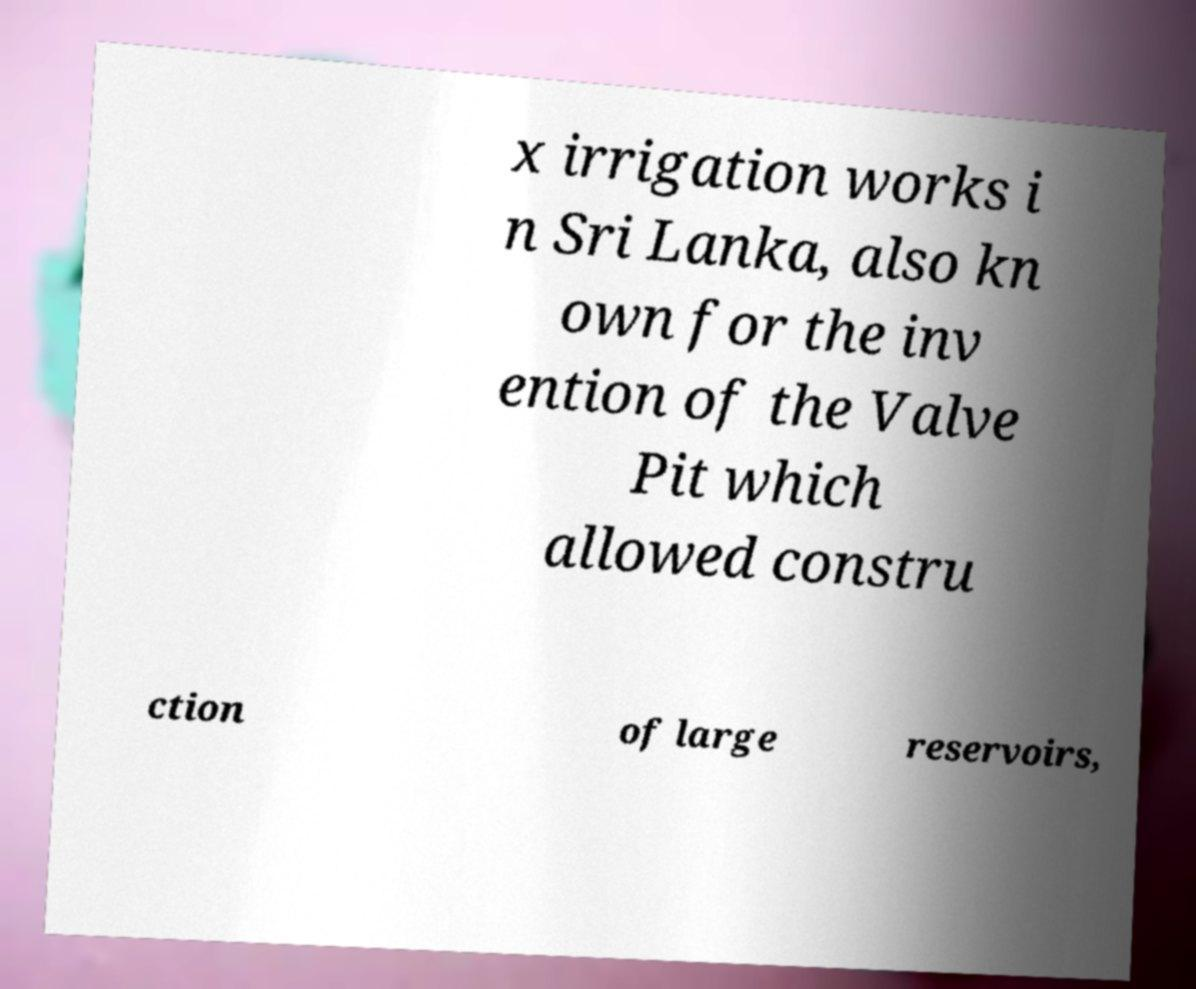Can you accurately transcribe the text from the provided image for me? x irrigation works i n Sri Lanka, also kn own for the inv ention of the Valve Pit which allowed constru ction of large reservoirs, 